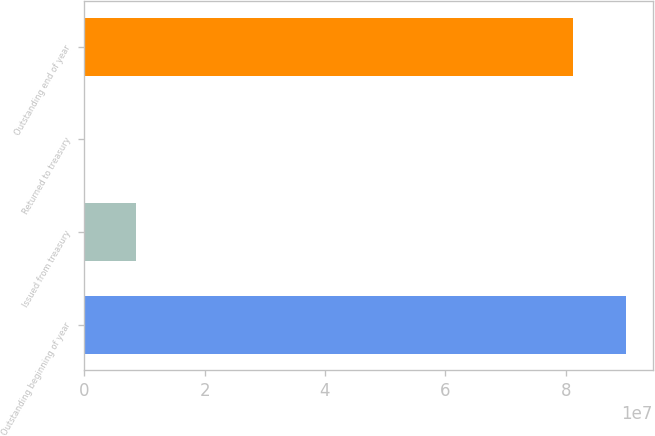Convert chart to OTSL. <chart><loc_0><loc_0><loc_500><loc_500><bar_chart><fcel>Outstanding beginning of year<fcel>Issued from treasury<fcel>Returned to treasury<fcel>Outstanding end of year<nl><fcel>8.996e+07<fcel>8.68628e+06<fcel>3077<fcel>8.12768e+07<nl></chart> 